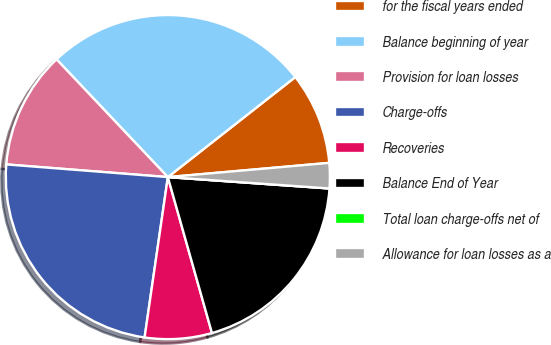<chart> <loc_0><loc_0><loc_500><loc_500><pie_chart><fcel>for the fiscal years ended<fcel>Balance beginning of year<fcel>Provision for loan losses<fcel>Charge-offs<fcel>Recoveries<fcel>Balance End of Year<fcel>Total loan charge-offs net of<fcel>Allowance for loan losses as a<nl><fcel>9.19%<fcel>26.46%<fcel>11.7%<fcel>23.95%<fcel>6.68%<fcel>19.49%<fcel>0.0%<fcel>2.52%<nl></chart> 